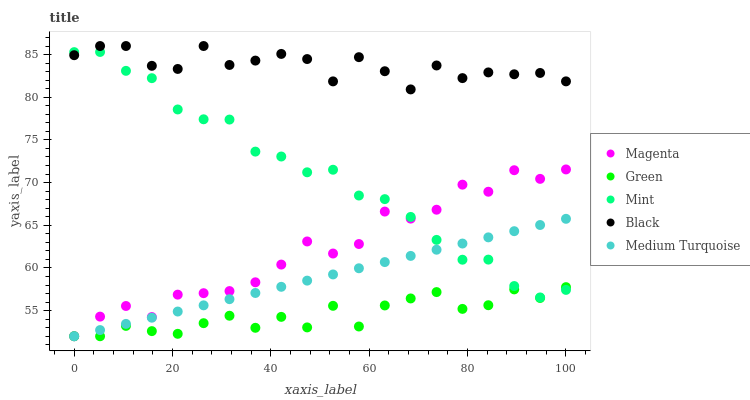Does Green have the minimum area under the curve?
Answer yes or no. Yes. Does Black have the maximum area under the curve?
Answer yes or no. Yes. Does Magenta have the minimum area under the curve?
Answer yes or no. No. Does Magenta have the maximum area under the curve?
Answer yes or no. No. Is Medium Turquoise the smoothest?
Answer yes or no. Yes. Is Black the roughest?
Answer yes or no. Yes. Is Magenta the smoothest?
Answer yes or no. No. Is Magenta the roughest?
Answer yes or no. No. Does Magenta have the lowest value?
Answer yes or no. Yes. Does Black have the lowest value?
Answer yes or no. No. Does Black have the highest value?
Answer yes or no. Yes. Does Magenta have the highest value?
Answer yes or no. No. Is Magenta less than Black?
Answer yes or no. Yes. Is Black greater than Magenta?
Answer yes or no. Yes. Does Medium Turquoise intersect Mint?
Answer yes or no. Yes. Is Medium Turquoise less than Mint?
Answer yes or no. No. Is Medium Turquoise greater than Mint?
Answer yes or no. No. Does Magenta intersect Black?
Answer yes or no. No. 